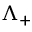Convert formula to latex. <formula><loc_0><loc_0><loc_500><loc_500>\Lambda _ { + }</formula> 